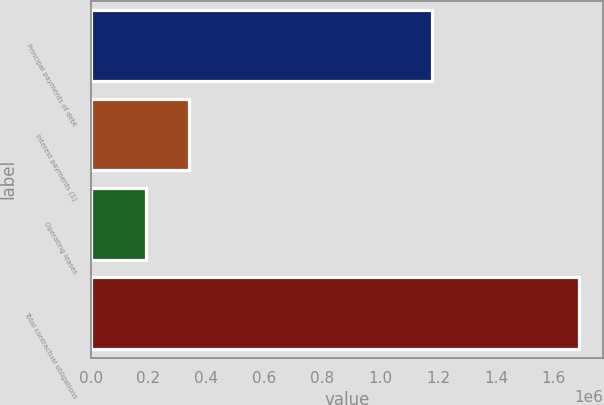Convert chart to OTSL. <chart><loc_0><loc_0><loc_500><loc_500><bar_chart><fcel>Principal payments of debt<fcel>Interest payments (1)<fcel>Operating leases<fcel>Total contractual obligations<nl><fcel>1.18e+06<fcel>340062<fcel>190538<fcel>1.68578e+06<nl></chart> 